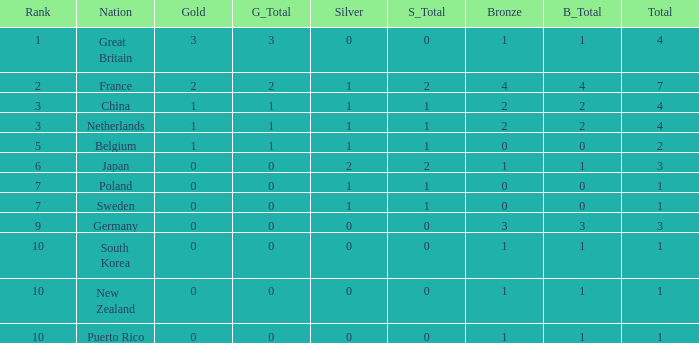What is the rank with 0 bronze? None. 